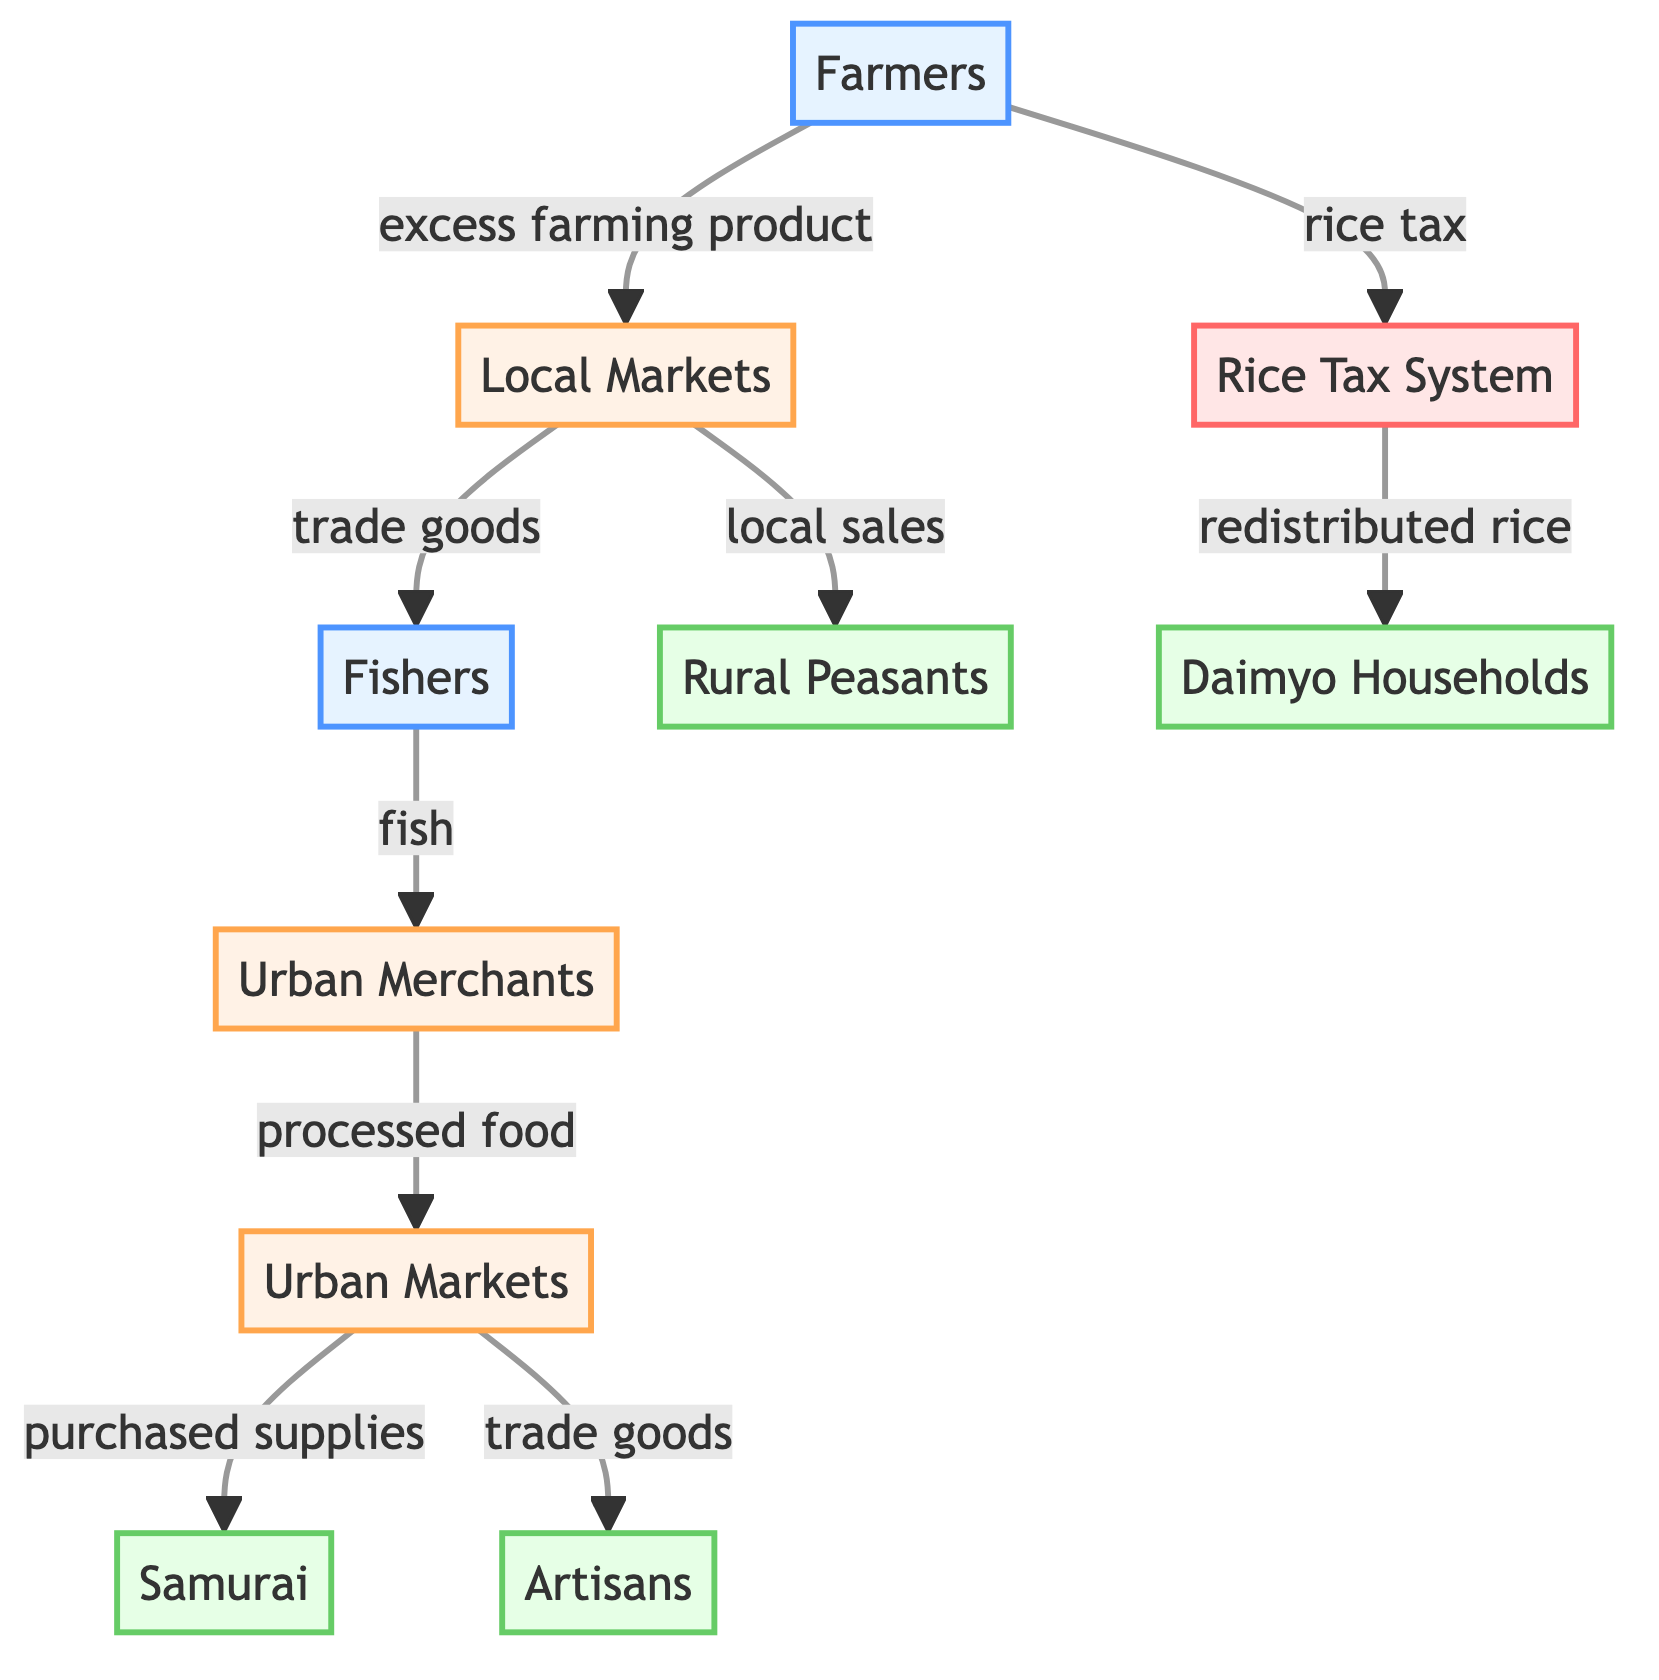What are the three types of producers in the diagram? The diagram lists "Farmers" and "Fishers" as the types of producers. There are no other producers present, making the total two.
Answer: Farmers, Fishers How many consumer nodes are there? The diagram shows four consumer nodes: "Rural Peasants," "Samurai," "Artisans," and "Daimyo Households." Therefore, the total is four consumer nodes.
Answer: 4 Which consumer receives rice through the tax system? The diagram indicates that "Daimyo Households" receive rice through the "Rice Tax System," as shown by the arrow linking these two nodes.
Answer: Daimyo Households Where do Urban Merchants obtain fish? According to the diagram, "Urban Merchants" obtain fish from "Fishers," as indicated by the directional arrow linking these two nodes.
Answer: Fishers How do local markets distribute goods to rural consumers? The diagram shows that "Local Markets" distribute goods to "Rural Peasants" through "local sales," indicating a direct relationship between these two nodes.
Answer: Local sales What is the flow from farmers to the local markets? The flow starts from "Farmers," who provide "excess farming product" to "Local Markets," indicating a transactional relationship between these nodes.
Answer: Excess farming product Which group is connected to the Urban Markets for trade goods? The diagram shows that "Urban Merchants" supply "Urban Markets" with "trade goods," indicating that the connection flows from Urban Merchants to Urban Markets.
Answer: Urban Merchants What role do Urban Markets play in the food distribution network? The diagram illustrates that "Urban Markets" play an intermediary role by dealing with "processed food" from "Urban Merchants" and redistributing it to consumers like "Samurai" and "Artisans."
Answer: Intermediary Who provides food through the fish supply chain? The "Fishers" are indicated as the source of food that flows to "Urban Merchants," establishing them as the initial point in the fish supply chain.
Answer: Fishers 